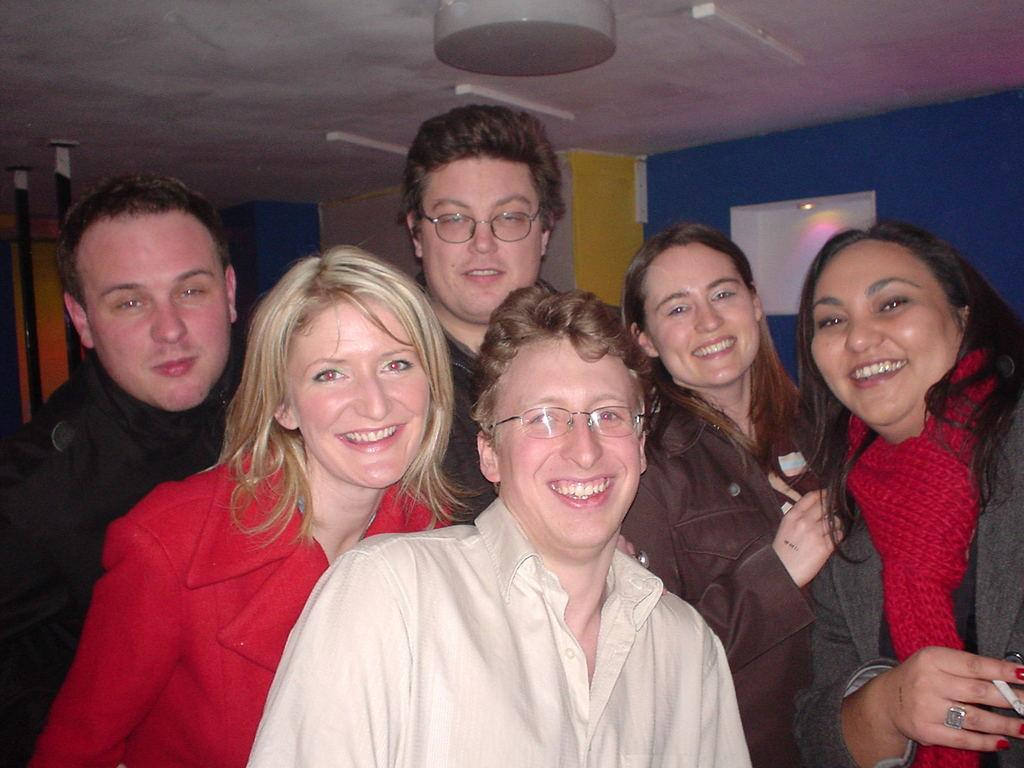Who or what can be seen in the image? There are people in the image. What is the background or setting of the image? There is a wall visible in the image. What type of cushion is being used by the people in the image? There is no cushion visible in the image. Can you hear any noise in the image? The image is silent, and we cannot hear any noise from it. 